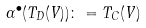Convert formula to latex. <formula><loc_0><loc_0><loc_500><loc_500>\alpha ^ { \bullet } ( T _ { D } ( V ) ) \colon = T _ { C } ( V )</formula> 